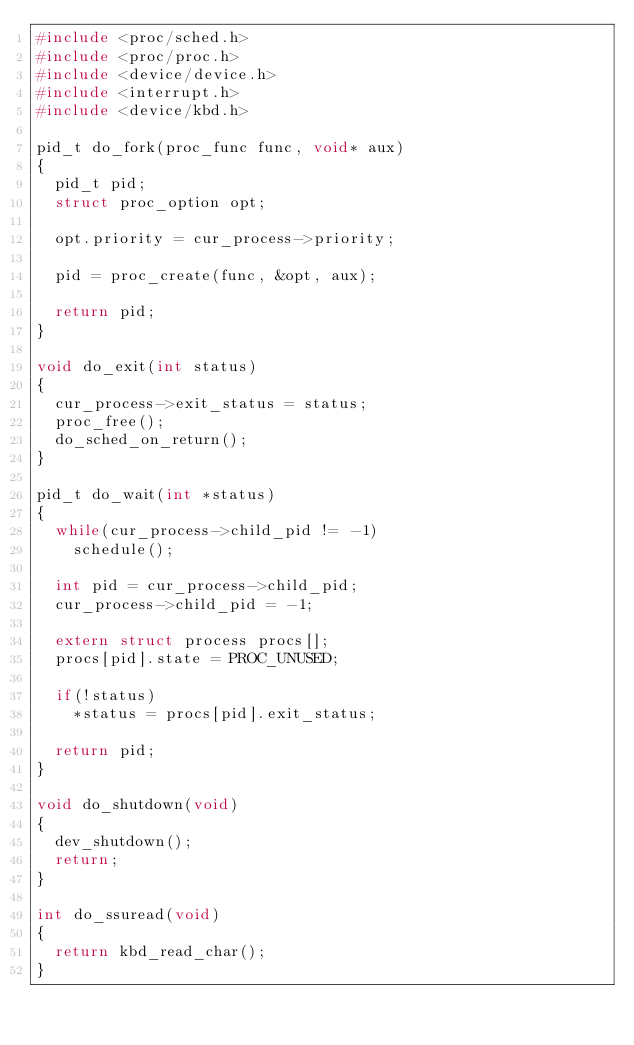Convert code to text. <code><loc_0><loc_0><loc_500><loc_500><_C_>#include <proc/sched.h>
#include <proc/proc.h>
#include <device/device.h>
#include <interrupt.h>
#include <device/kbd.h>

pid_t do_fork(proc_func func, void* aux)
{
	pid_t pid;
	struct proc_option opt;

	opt.priority = cur_process->priority;
	
	pid = proc_create(func, &opt, aux);

	return pid;
}

void do_exit(int status)
{
	cur_process->exit_status = status; 
	proc_free();
	do_sched_on_return();	
}

pid_t do_wait(int *status)
{
	while(cur_process->child_pid != -1)
		schedule();
	
	int pid = cur_process->child_pid;
	cur_process->child_pid = -1;

	extern struct process procs[];
	procs[pid].state = PROC_UNUSED;

	if(!status)
		*status = procs[pid].exit_status;

	return pid;
}

void do_shutdown(void)
{
	dev_shutdown();
	return;
}

int do_ssuread(void)
{
	return kbd_read_char();
}
</code> 